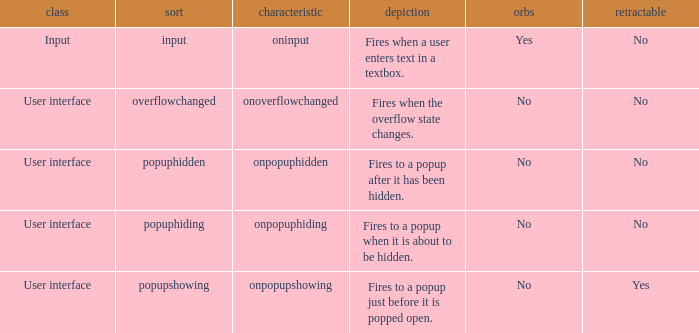What's the type with description being fires when the overflow state changes. Overflowchanged. 